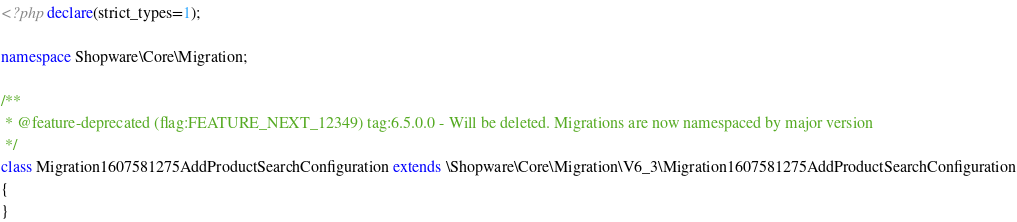Convert code to text. <code><loc_0><loc_0><loc_500><loc_500><_PHP_><?php declare(strict_types=1);

namespace Shopware\Core\Migration;

/**
 * @feature-deprecated (flag:FEATURE_NEXT_12349) tag:6.5.0.0 - Will be deleted. Migrations are now namespaced by major version
 */
class Migration1607581275AddProductSearchConfiguration extends \Shopware\Core\Migration\V6_3\Migration1607581275AddProductSearchConfiguration
{
}
</code> 